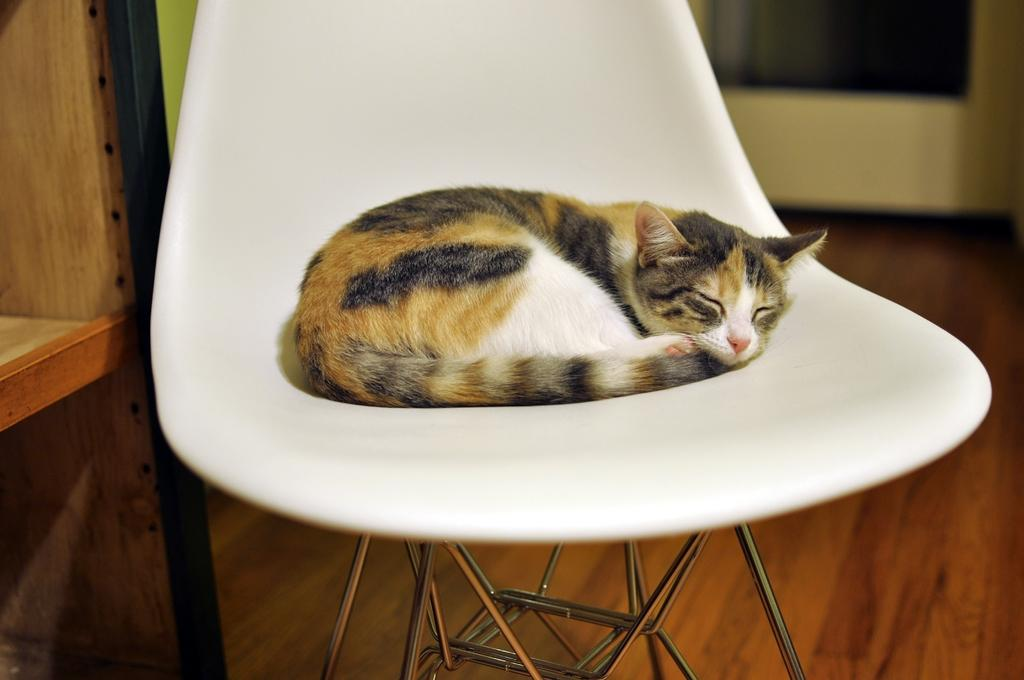What type of animal is in the image? There is a cat in the image. What is the cat doing in the image? The cat is sleeping. What is the cat sitting on in the image? The cat is in a white color chair. What can be seen in the background of the image? There is a wooden rack in the background of the image. What type of plastic material is covering the cat in the image? There is no plastic material covering the cat in the image; the cat is simply sleeping in a white color chair. 